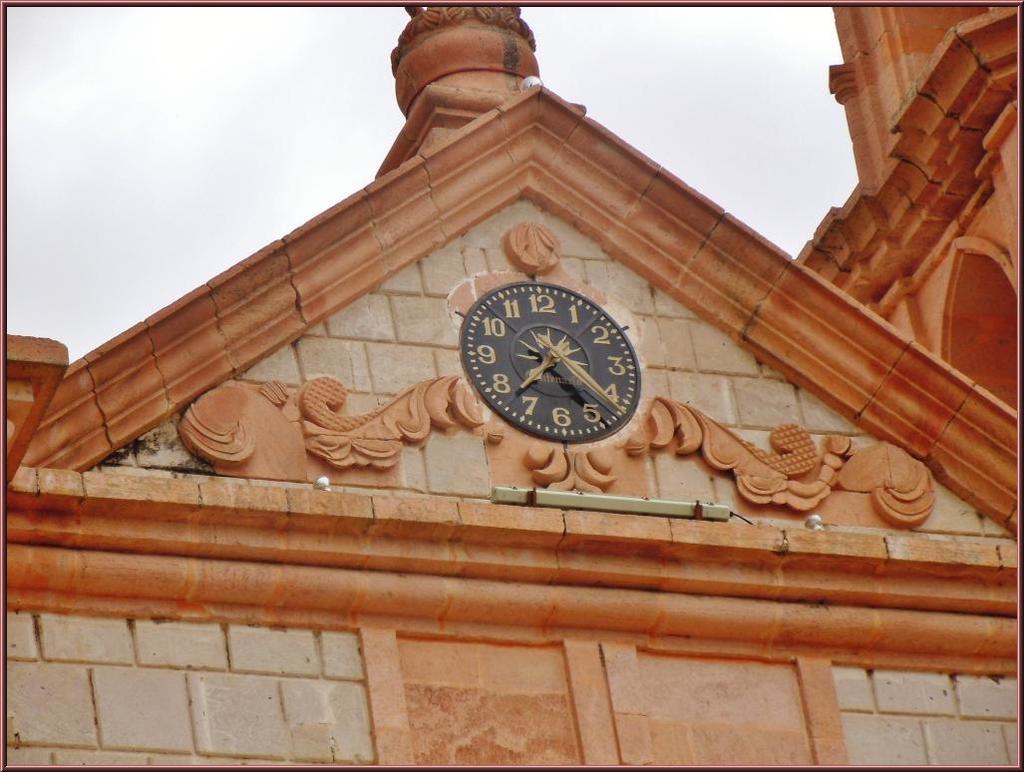What is the time?
Your answer should be compact. 7:22. The time is 7:25?
Ensure brevity in your answer.  No. 